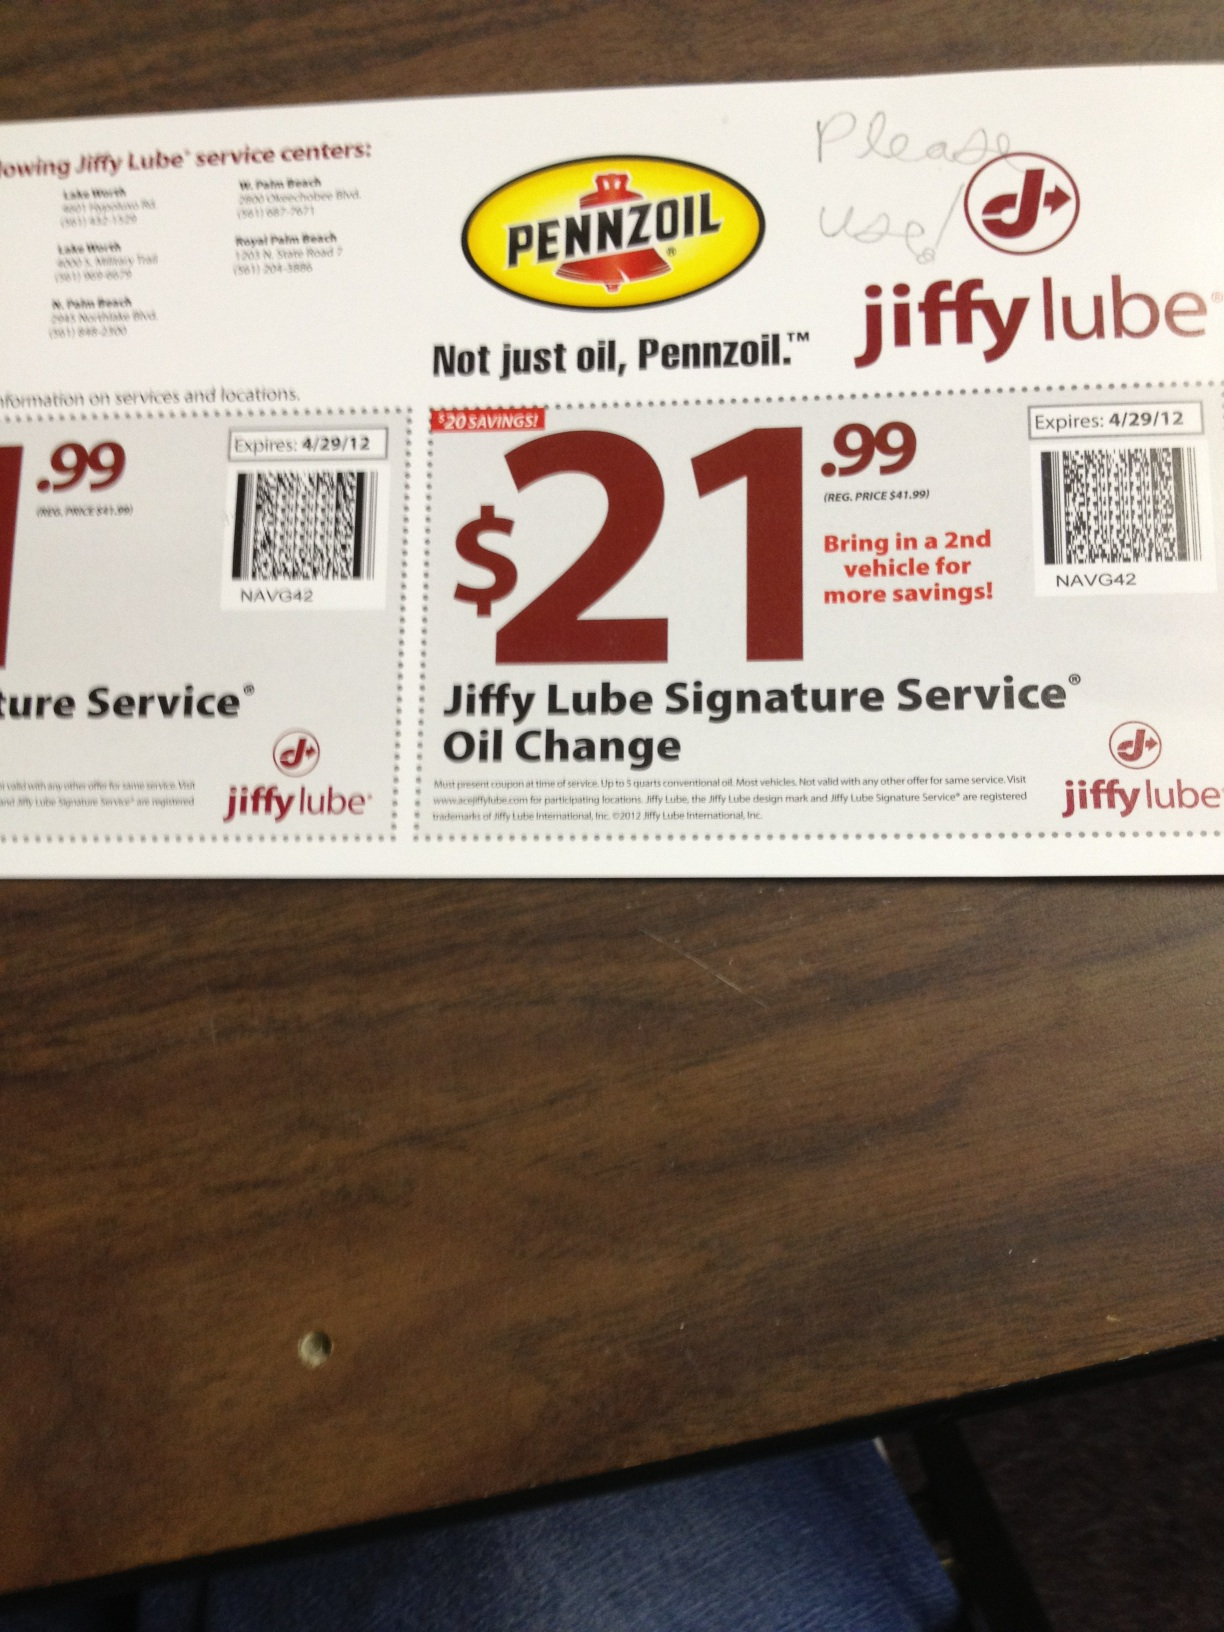Provide a detailed scenario of using this coupon. You just noticed that your car is due for an oil change, so you decide to use the Jiffy Lube coupon you have. You call ahead to confirm that your local Jiffy Lube accepts the coupon and make an appointment. At the service center, you present the coupon to the attendant, who confirms its validity. They take your car in for the service, which includes a thorough oil change with Pennzoil, as well as topping up essential fluids and inspecting various components of your vehicle. After the service, your car is running smoothly, and you pay the discounted price of $21.99, saving $20 from the regular price. Pleased with the efficient service and savings, you make a mental note to bring your second vehicle for the sharegpt4v/same service within the coupon's validity period. 